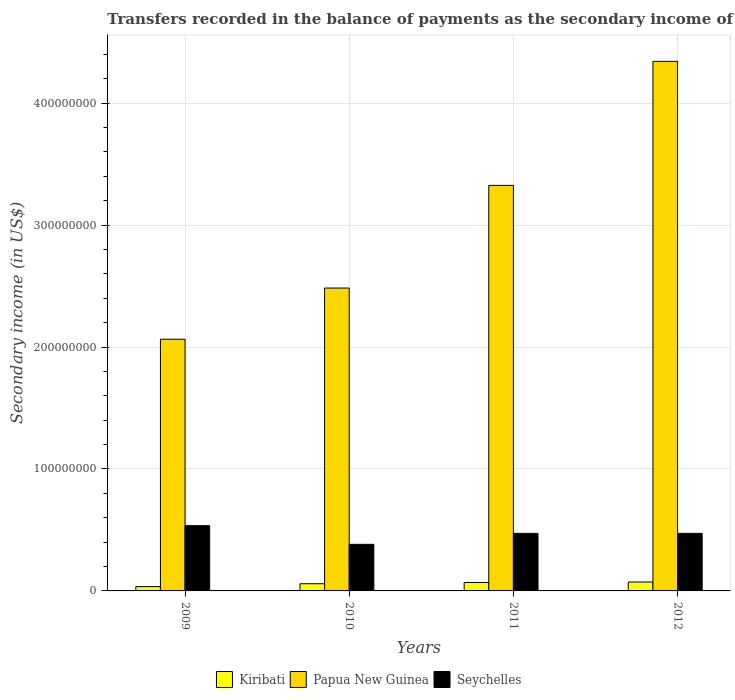How many groups of bars are there?
Provide a succinct answer. 4. Are the number of bars on each tick of the X-axis equal?
Keep it short and to the point. Yes. How many bars are there on the 4th tick from the right?
Your response must be concise. 3. What is the label of the 3rd group of bars from the left?
Offer a very short reply. 2011. In how many cases, is the number of bars for a given year not equal to the number of legend labels?
Make the answer very short. 0. What is the secondary income of in Kiribati in 2012?
Ensure brevity in your answer.  7.31e+06. Across all years, what is the maximum secondary income of in Papua New Guinea?
Your response must be concise. 4.34e+08. Across all years, what is the minimum secondary income of in Seychelles?
Give a very brief answer. 3.82e+07. In which year was the secondary income of in Papua New Guinea maximum?
Make the answer very short. 2012. In which year was the secondary income of in Kiribati minimum?
Your response must be concise. 2009. What is the total secondary income of in Kiribati in the graph?
Offer a terse response. 2.37e+07. What is the difference between the secondary income of in Papua New Guinea in 2010 and that in 2011?
Give a very brief answer. -8.42e+07. What is the difference between the secondary income of in Kiribati in 2010 and the secondary income of in Seychelles in 2009?
Give a very brief answer. -4.76e+07. What is the average secondary income of in Papua New Guinea per year?
Provide a succinct answer. 3.05e+08. In the year 2010, what is the difference between the secondary income of in Seychelles and secondary income of in Papua New Guinea?
Your response must be concise. -2.10e+08. What is the ratio of the secondary income of in Seychelles in 2011 to that in 2012?
Your response must be concise. 1. Is the secondary income of in Papua New Guinea in 2009 less than that in 2010?
Your answer should be compact. Yes. What is the difference between the highest and the second highest secondary income of in Kiribati?
Make the answer very short. 3.91e+05. What is the difference between the highest and the lowest secondary income of in Seychelles?
Your answer should be compact. 1.53e+07. What does the 2nd bar from the left in 2011 represents?
Your answer should be compact. Papua New Guinea. What does the 1st bar from the right in 2012 represents?
Make the answer very short. Seychelles. Is it the case that in every year, the sum of the secondary income of in Papua New Guinea and secondary income of in Kiribati is greater than the secondary income of in Seychelles?
Provide a short and direct response. Yes. How many years are there in the graph?
Provide a short and direct response. 4. What is the difference between two consecutive major ticks on the Y-axis?
Your answer should be very brief. 1.00e+08. Does the graph contain any zero values?
Offer a terse response. No. Where does the legend appear in the graph?
Provide a short and direct response. Bottom center. How many legend labels are there?
Keep it short and to the point. 3. What is the title of the graph?
Provide a short and direct response. Transfers recorded in the balance of payments as the secondary income of a country. What is the label or title of the Y-axis?
Provide a succinct answer. Secondary income (in US$). What is the Secondary income (in US$) of Kiribati in 2009?
Provide a short and direct response. 3.55e+06. What is the Secondary income (in US$) of Papua New Guinea in 2009?
Provide a succinct answer. 2.06e+08. What is the Secondary income (in US$) in Seychelles in 2009?
Your response must be concise. 5.35e+07. What is the Secondary income (in US$) in Kiribati in 2010?
Keep it short and to the point. 5.89e+06. What is the Secondary income (in US$) of Papua New Guinea in 2010?
Your answer should be very brief. 2.48e+08. What is the Secondary income (in US$) in Seychelles in 2010?
Make the answer very short. 3.82e+07. What is the Secondary income (in US$) in Kiribati in 2011?
Give a very brief answer. 6.92e+06. What is the Secondary income (in US$) of Papua New Guinea in 2011?
Give a very brief answer. 3.33e+08. What is the Secondary income (in US$) in Seychelles in 2011?
Make the answer very short. 4.72e+07. What is the Secondary income (in US$) in Kiribati in 2012?
Your answer should be compact. 7.31e+06. What is the Secondary income (in US$) of Papua New Guinea in 2012?
Your response must be concise. 4.34e+08. What is the Secondary income (in US$) of Seychelles in 2012?
Make the answer very short. 4.72e+07. Across all years, what is the maximum Secondary income (in US$) in Kiribati?
Your answer should be very brief. 7.31e+06. Across all years, what is the maximum Secondary income (in US$) in Papua New Guinea?
Offer a terse response. 4.34e+08. Across all years, what is the maximum Secondary income (in US$) in Seychelles?
Offer a very short reply. 5.35e+07. Across all years, what is the minimum Secondary income (in US$) in Kiribati?
Ensure brevity in your answer.  3.55e+06. Across all years, what is the minimum Secondary income (in US$) of Papua New Guinea?
Your answer should be very brief. 2.06e+08. Across all years, what is the minimum Secondary income (in US$) in Seychelles?
Give a very brief answer. 3.82e+07. What is the total Secondary income (in US$) of Kiribati in the graph?
Your answer should be very brief. 2.37e+07. What is the total Secondary income (in US$) of Papua New Guinea in the graph?
Ensure brevity in your answer.  1.22e+09. What is the total Secondary income (in US$) in Seychelles in the graph?
Your answer should be very brief. 1.86e+08. What is the difference between the Secondary income (in US$) of Kiribati in 2009 and that in 2010?
Ensure brevity in your answer.  -2.35e+06. What is the difference between the Secondary income (in US$) of Papua New Guinea in 2009 and that in 2010?
Give a very brief answer. -4.20e+07. What is the difference between the Secondary income (in US$) in Seychelles in 2009 and that in 2010?
Make the answer very short. 1.53e+07. What is the difference between the Secondary income (in US$) in Kiribati in 2009 and that in 2011?
Provide a short and direct response. -3.37e+06. What is the difference between the Secondary income (in US$) of Papua New Guinea in 2009 and that in 2011?
Provide a succinct answer. -1.26e+08. What is the difference between the Secondary income (in US$) in Seychelles in 2009 and that in 2011?
Your answer should be very brief. 6.34e+06. What is the difference between the Secondary income (in US$) of Kiribati in 2009 and that in 2012?
Your answer should be very brief. -3.76e+06. What is the difference between the Secondary income (in US$) of Papua New Guinea in 2009 and that in 2012?
Provide a succinct answer. -2.28e+08. What is the difference between the Secondary income (in US$) of Seychelles in 2009 and that in 2012?
Your answer should be compact. 6.32e+06. What is the difference between the Secondary income (in US$) in Kiribati in 2010 and that in 2011?
Give a very brief answer. -1.03e+06. What is the difference between the Secondary income (in US$) of Papua New Guinea in 2010 and that in 2011?
Provide a succinct answer. -8.42e+07. What is the difference between the Secondary income (in US$) of Seychelles in 2010 and that in 2011?
Give a very brief answer. -9.00e+06. What is the difference between the Secondary income (in US$) in Kiribati in 2010 and that in 2012?
Provide a succinct answer. -1.42e+06. What is the difference between the Secondary income (in US$) of Papua New Guinea in 2010 and that in 2012?
Offer a very short reply. -1.86e+08. What is the difference between the Secondary income (in US$) of Seychelles in 2010 and that in 2012?
Provide a short and direct response. -9.02e+06. What is the difference between the Secondary income (in US$) of Kiribati in 2011 and that in 2012?
Your answer should be very brief. -3.91e+05. What is the difference between the Secondary income (in US$) of Papua New Guinea in 2011 and that in 2012?
Your answer should be compact. -1.02e+08. What is the difference between the Secondary income (in US$) in Seychelles in 2011 and that in 2012?
Offer a terse response. -1.91e+04. What is the difference between the Secondary income (in US$) of Kiribati in 2009 and the Secondary income (in US$) of Papua New Guinea in 2010?
Your answer should be compact. -2.45e+08. What is the difference between the Secondary income (in US$) of Kiribati in 2009 and the Secondary income (in US$) of Seychelles in 2010?
Offer a very short reply. -3.47e+07. What is the difference between the Secondary income (in US$) of Papua New Guinea in 2009 and the Secondary income (in US$) of Seychelles in 2010?
Provide a succinct answer. 1.68e+08. What is the difference between the Secondary income (in US$) in Kiribati in 2009 and the Secondary income (in US$) in Papua New Guinea in 2011?
Give a very brief answer. -3.29e+08. What is the difference between the Secondary income (in US$) of Kiribati in 2009 and the Secondary income (in US$) of Seychelles in 2011?
Keep it short and to the point. -4.37e+07. What is the difference between the Secondary income (in US$) in Papua New Guinea in 2009 and the Secondary income (in US$) in Seychelles in 2011?
Make the answer very short. 1.59e+08. What is the difference between the Secondary income (in US$) in Kiribati in 2009 and the Secondary income (in US$) in Papua New Guinea in 2012?
Make the answer very short. -4.31e+08. What is the difference between the Secondary income (in US$) of Kiribati in 2009 and the Secondary income (in US$) of Seychelles in 2012?
Offer a terse response. -4.37e+07. What is the difference between the Secondary income (in US$) in Papua New Guinea in 2009 and the Secondary income (in US$) in Seychelles in 2012?
Offer a terse response. 1.59e+08. What is the difference between the Secondary income (in US$) of Kiribati in 2010 and the Secondary income (in US$) of Papua New Guinea in 2011?
Offer a very short reply. -3.27e+08. What is the difference between the Secondary income (in US$) in Kiribati in 2010 and the Secondary income (in US$) in Seychelles in 2011?
Your answer should be very brief. -4.13e+07. What is the difference between the Secondary income (in US$) of Papua New Guinea in 2010 and the Secondary income (in US$) of Seychelles in 2011?
Make the answer very short. 2.01e+08. What is the difference between the Secondary income (in US$) of Kiribati in 2010 and the Secondary income (in US$) of Papua New Guinea in 2012?
Give a very brief answer. -4.28e+08. What is the difference between the Secondary income (in US$) of Kiribati in 2010 and the Secondary income (in US$) of Seychelles in 2012?
Provide a succinct answer. -4.13e+07. What is the difference between the Secondary income (in US$) of Papua New Guinea in 2010 and the Secondary income (in US$) of Seychelles in 2012?
Offer a very short reply. 2.01e+08. What is the difference between the Secondary income (in US$) of Kiribati in 2011 and the Secondary income (in US$) of Papua New Guinea in 2012?
Give a very brief answer. -4.27e+08. What is the difference between the Secondary income (in US$) in Kiribati in 2011 and the Secondary income (in US$) in Seychelles in 2012?
Your response must be concise. -4.03e+07. What is the difference between the Secondary income (in US$) in Papua New Guinea in 2011 and the Secondary income (in US$) in Seychelles in 2012?
Offer a very short reply. 2.85e+08. What is the average Secondary income (in US$) of Kiribati per year?
Provide a short and direct response. 5.92e+06. What is the average Secondary income (in US$) of Papua New Guinea per year?
Make the answer very short. 3.05e+08. What is the average Secondary income (in US$) in Seychelles per year?
Provide a short and direct response. 4.65e+07. In the year 2009, what is the difference between the Secondary income (in US$) of Kiribati and Secondary income (in US$) of Papua New Guinea?
Provide a short and direct response. -2.03e+08. In the year 2009, what is the difference between the Secondary income (in US$) of Kiribati and Secondary income (in US$) of Seychelles?
Ensure brevity in your answer.  -5.00e+07. In the year 2009, what is the difference between the Secondary income (in US$) in Papua New Guinea and Secondary income (in US$) in Seychelles?
Ensure brevity in your answer.  1.53e+08. In the year 2010, what is the difference between the Secondary income (in US$) of Kiribati and Secondary income (in US$) of Papua New Guinea?
Ensure brevity in your answer.  -2.43e+08. In the year 2010, what is the difference between the Secondary income (in US$) in Kiribati and Secondary income (in US$) in Seychelles?
Provide a succinct answer. -3.23e+07. In the year 2010, what is the difference between the Secondary income (in US$) in Papua New Guinea and Secondary income (in US$) in Seychelles?
Keep it short and to the point. 2.10e+08. In the year 2011, what is the difference between the Secondary income (in US$) of Kiribati and Secondary income (in US$) of Papua New Guinea?
Keep it short and to the point. -3.26e+08. In the year 2011, what is the difference between the Secondary income (in US$) in Kiribati and Secondary income (in US$) in Seychelles?
Your answer should be very brief. -4.03e+07. In the year 2011, what is the difference between the Secondary income (in US$) of Papua New Guinea and Secondary income (in US$) of Seychelles?
Your answer should be very brief. 2.85e+08. In the year 2012, what is the difference between the Secondary income (in US$) of Kiribati and Secondary income (in US$) of Papua New Guinea?
Offer a terse response. -4.27e+08. In the year 2012, what is the difference between the Secondary income (in US$) of Kiribati and Secondary income (in US$) of Seychelles?
Your answer should be compact. -3.99e+07. In the year 2012, what is the difference between the Secondary income (in US$) of Papua New Guinea and Secondary income (in US$) of Seychelles?
Make the answer very short. 3.87e+08. What is the ratio of the Secondary income (in US$) of Kiribati in 2009 to that in 2010?
Offer a very short reply. 0.6. What is the ratio of the Secondary income (in US$) in Papua New Guinea in 2009 to that in 2010?
Provide a succinct answer. 0.83. What is the ratio of the Secondary income (in US$) of Seychelles in 2009 to that in 2010?
Provide a succinct answer. 1.4. What is the ratio of the Secondary income (in US$) in Kiribati in 2009 to that in 2011?
Make the answer very short. 0.51. What is the ratio of the Secondary income (in US$) in Papua New Guinea in 2009 to that in 2011?
Your answer should be very brief. 0.62. What is the ratio of the Secondary income (in US$) of Seychelles in 2009 to that in 2011?
Keep it short and to the point. 1.13. What is the ratio of the Secondary income (in US$) in Kiribati in 2009 to that in 2012?
Ensure brevity in your answer.  0.49. What is the ratio of the Secondary income (in US$) in Papua New Guinea in 2009 to that in 2012?
Your answer should be very brief. 0.48. What is the ratio of the Secondary income (in US$) of Seychelles in 2009 to that in 2012?
Your answer should be very brief. 1.13. What is the ratio of the Secondary income (in US$) in Kiribati in 2010 to that in 2011?
Offer a very short reply. 0.85. What is the ratio of the Secondary income (in US$) in Papua New Guinea in 2010 to that in 2011?
Keep it short and to the point. 0.75. What is the ratio of the Secondary income (in US$) in Seychelles in 2010 to that in 2011?
Offer a very short reply. 0.81. What is the ratio of the Secondary income (in US$) in Kiribati in 2010 to that in 2012?
Ensure brevity in your answer.  0.81. What is the ratio of the Secondary income (in US$) of Papua New Guinea in 2010 to that in 2012?
Your answer should be very brief. 0.57. What is the ratio of the Secondary income (in US$) of Seychelles in 2010 to that in 2012?
Your response must be concise. 0.81. What is the ratio of the Secondary income (in US$) of Kiribati in 2011 to that in 2012?
Make the answer very short. 0.95. What is the ratio of the Secondary income (in US$) of Papua New Guinea in 2011 to that in 2012?
Keep it short and to the point. 0.77. What is the ratio of the Secondary income (in US$) of Seychelles in 2011 to that in 2012?
Your answer should be compact. 1. What is the difference between the highest and the second highest Secondary income (in US$) of Kiribati?
Your response must be concise. 3.91e+05. What is the difference between the highest and the second highest Secondary income (in US$) in Papua New Guinea?
Offer a very short reply. 1.02e+08. What is the difference between the highest and the second highest Secondary income (in US$) in Seychelles?
Provide a succinct answer. 6.32e+06. What is the difference between the highest and the lowest Secondary income (in US$) of Kiribati?
Offer a very short reply. 3.76e+06. What is the difference between the highest and the lowest Secondary income (in US$) in Papua New Guinea?
Your answer should be very brief. 2.28e+08. What is the difference between the highest and the lowest Secondary income (in US$) in Seychelles?
Keep it short and to the point. 1.53e+07. 